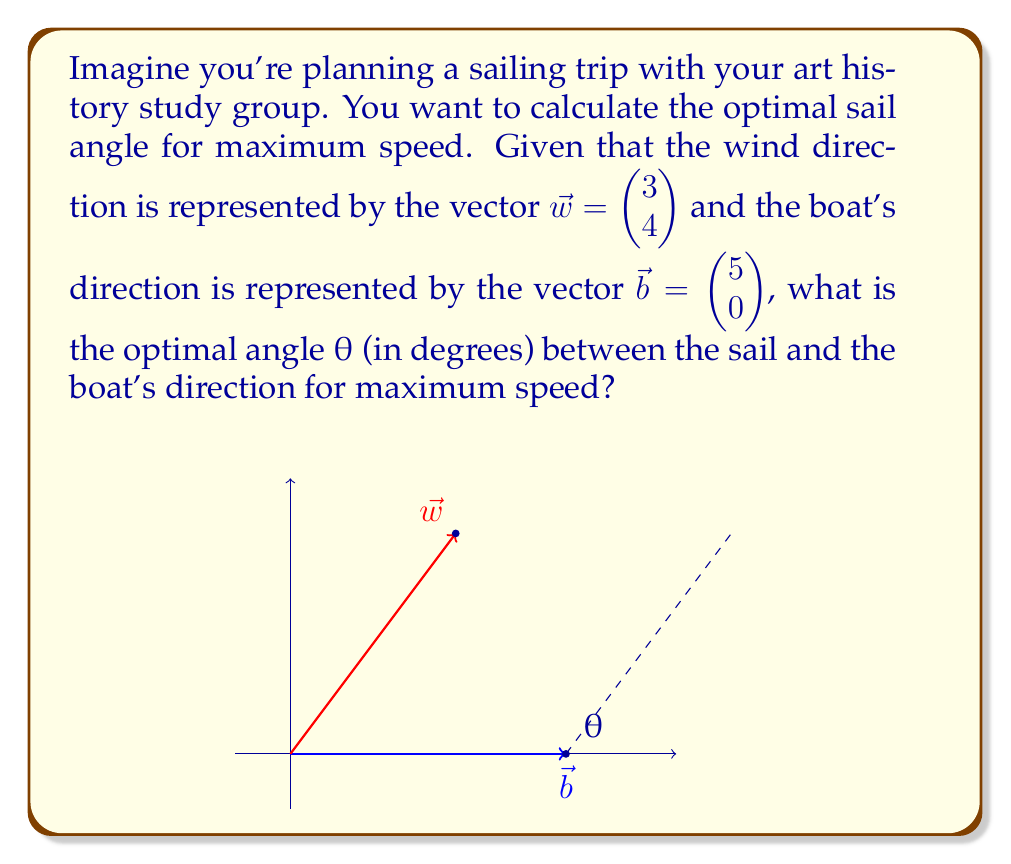What is the answer to this math problem? Let's approach this step-by-step:

1) The optimal sail angle for maximum speed is achieved when the sail bisects the angle between the wind direction and the boat's direction.

2) To find this angle, we need to calculate the angle between $\vec{w}$ and $\vec{b}$, and then divide it by 2.

3) We can use the dot product formula to find the angle between these vectors:

   $$\cos \phi = \frac{\vec{w} \cdot \vec{b}}{|\vec{w}| |\vec{b}|}$$

4) Let's calculate each part:
   
   $\vec{w} \cdot \vec{b} = 3(5) + 4(0) = 15$
   
   $|\vec{w}| = \sqrt{3^2 + 4^2} = 5$
   
   $|\vec{b}| = \sqrt{5^2 + 0^2} = 5$

5) Substituting into the formula:

   $$\cos \phi = \frac{15}{5 \cdot 5} = \frac{3}{5}$$

6) Taking the inverse cosine (arccos):

   $$\phi = \arccos(\frac{3}{5}) \approx 0.9273 \text{ radians}$$

7) Converting to degrees:

   $$\phi \approx 53.13°$$

8) The optimal sail angle θ is half of this:

   $$θ = \frac{\phi}{2} \approx 26.57°$$

This angle should be measured from the boat's direction towards the wind direction.
Answer: The optimal sail angle θ for maximum speed is approximately 26.57°. 